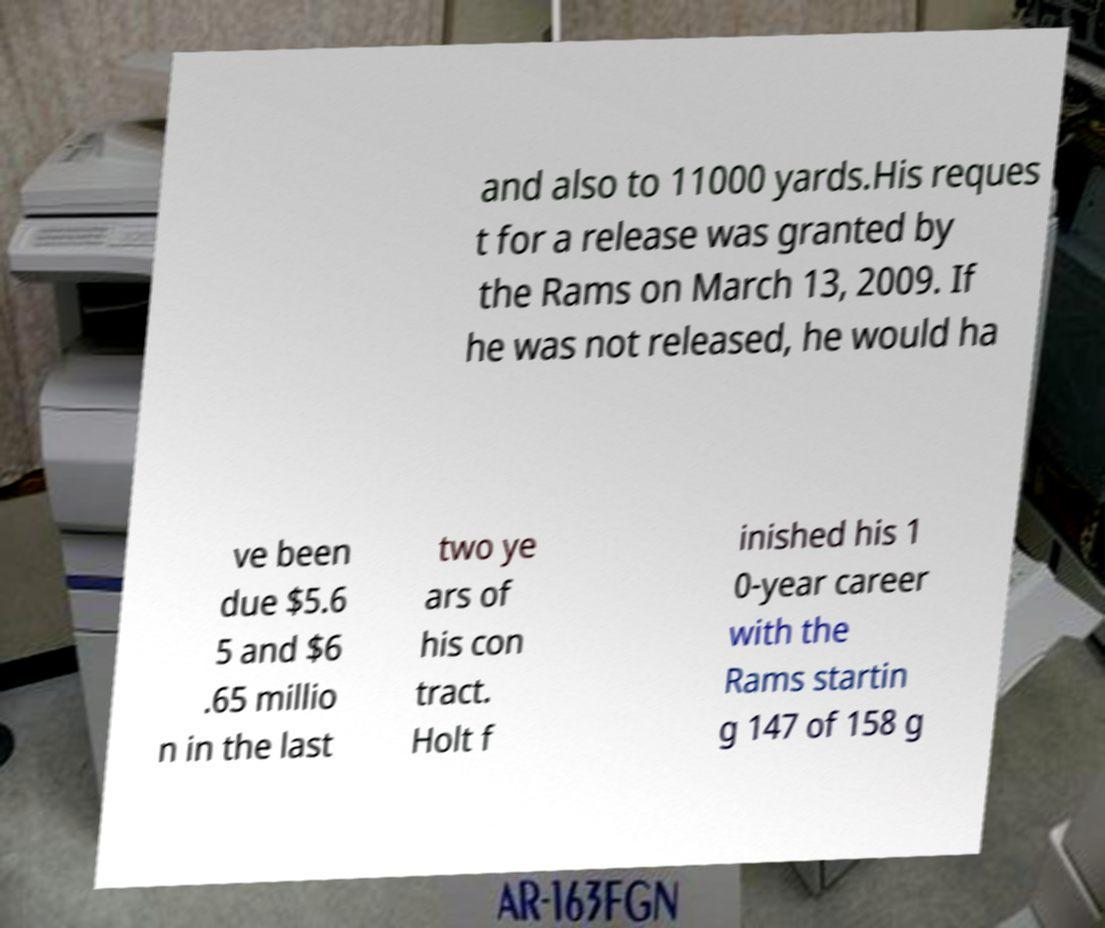Can you read and provide the text displayed in the image?This photo seems to have some interesting text. Can you extract and type it out for me? and also to 11000 yards.His reques t for a release was granted by the Rams on March 13, 2009. If he was not released, he would ha ve been due $5.6 5 and $6 .65 millio n in the last two ye ars of his con tract. Holt f inished his 1 0-year career with the Rams startin g 147 of 158 g 